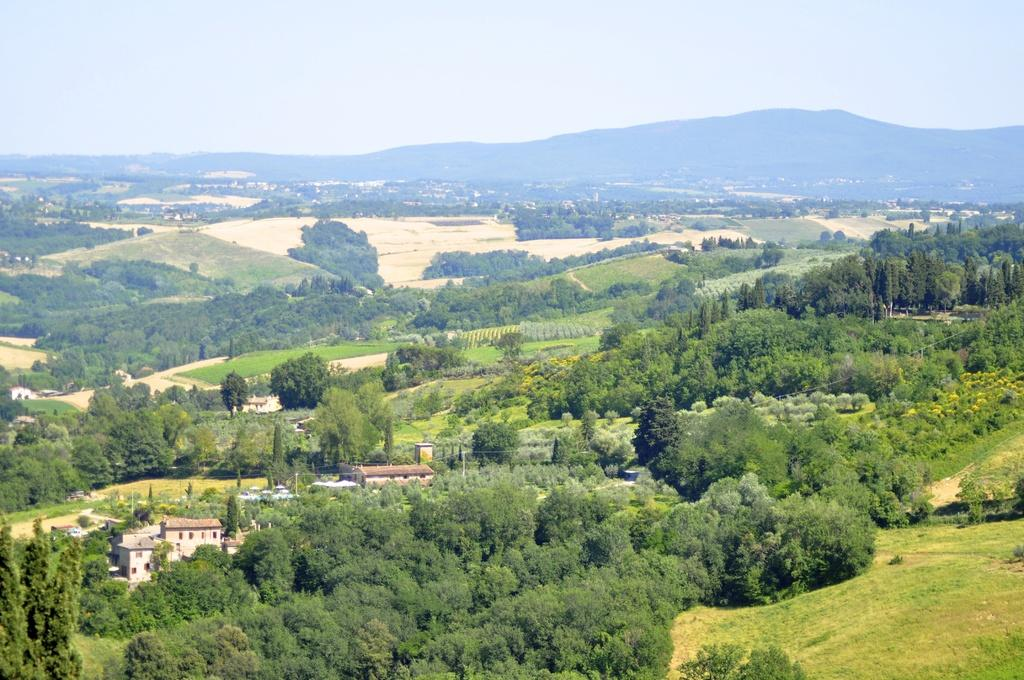What type of natural elements can be seen in the image? There are trees in the image. What type of man-made structures are present in the image? There are houses in the image. What type of geographical features can be seen in the image? There are hills in the image. What is visible in the background of the image? The sky is visible in the background of the image. Can you see a line of snakes rubbing against each other in the image? There are no snakes or lines of snakes present in the image; it features trees, houses, hills, and the sky. 